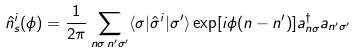Convert formula to latex. <formula><loc_0><loc_0><loc_500><loc_500>\hat { n } _ { s } ^ { i } ( \phi ) = \frac { 1 } { 2 \pi } \sum _ { n \sigma \, n ^ { \prime } \sigma ^ { \prime } } \langle \sigma | \hat { \sigma } ^ { i } | \sigma ^ { \prime } \rangle \exp [ i \phi ( n - n ^ { \prime } ) ] a ^ { \dagger } _ { n \sigma } a _ { n ^ { \prime } \sigma ^ { \prime } }</formula> 